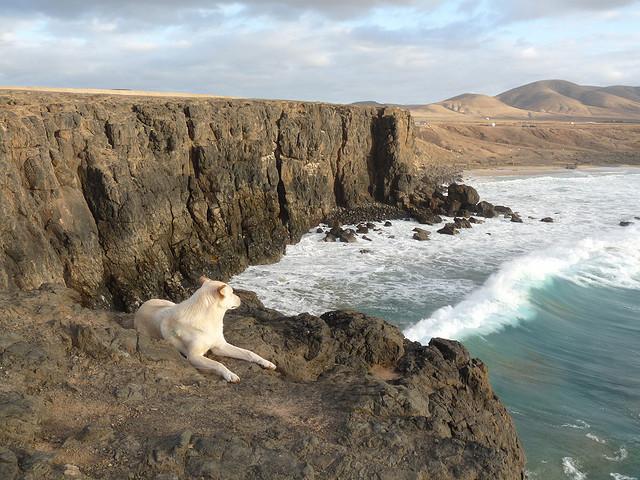What color is the dog?
Short answer required. White. Could this be a contained environment?
Quick response, please. No. What is the dog doing?
Keep it brief. Laying down. Overcast or sunny?
Keep it brief. Overcast. 